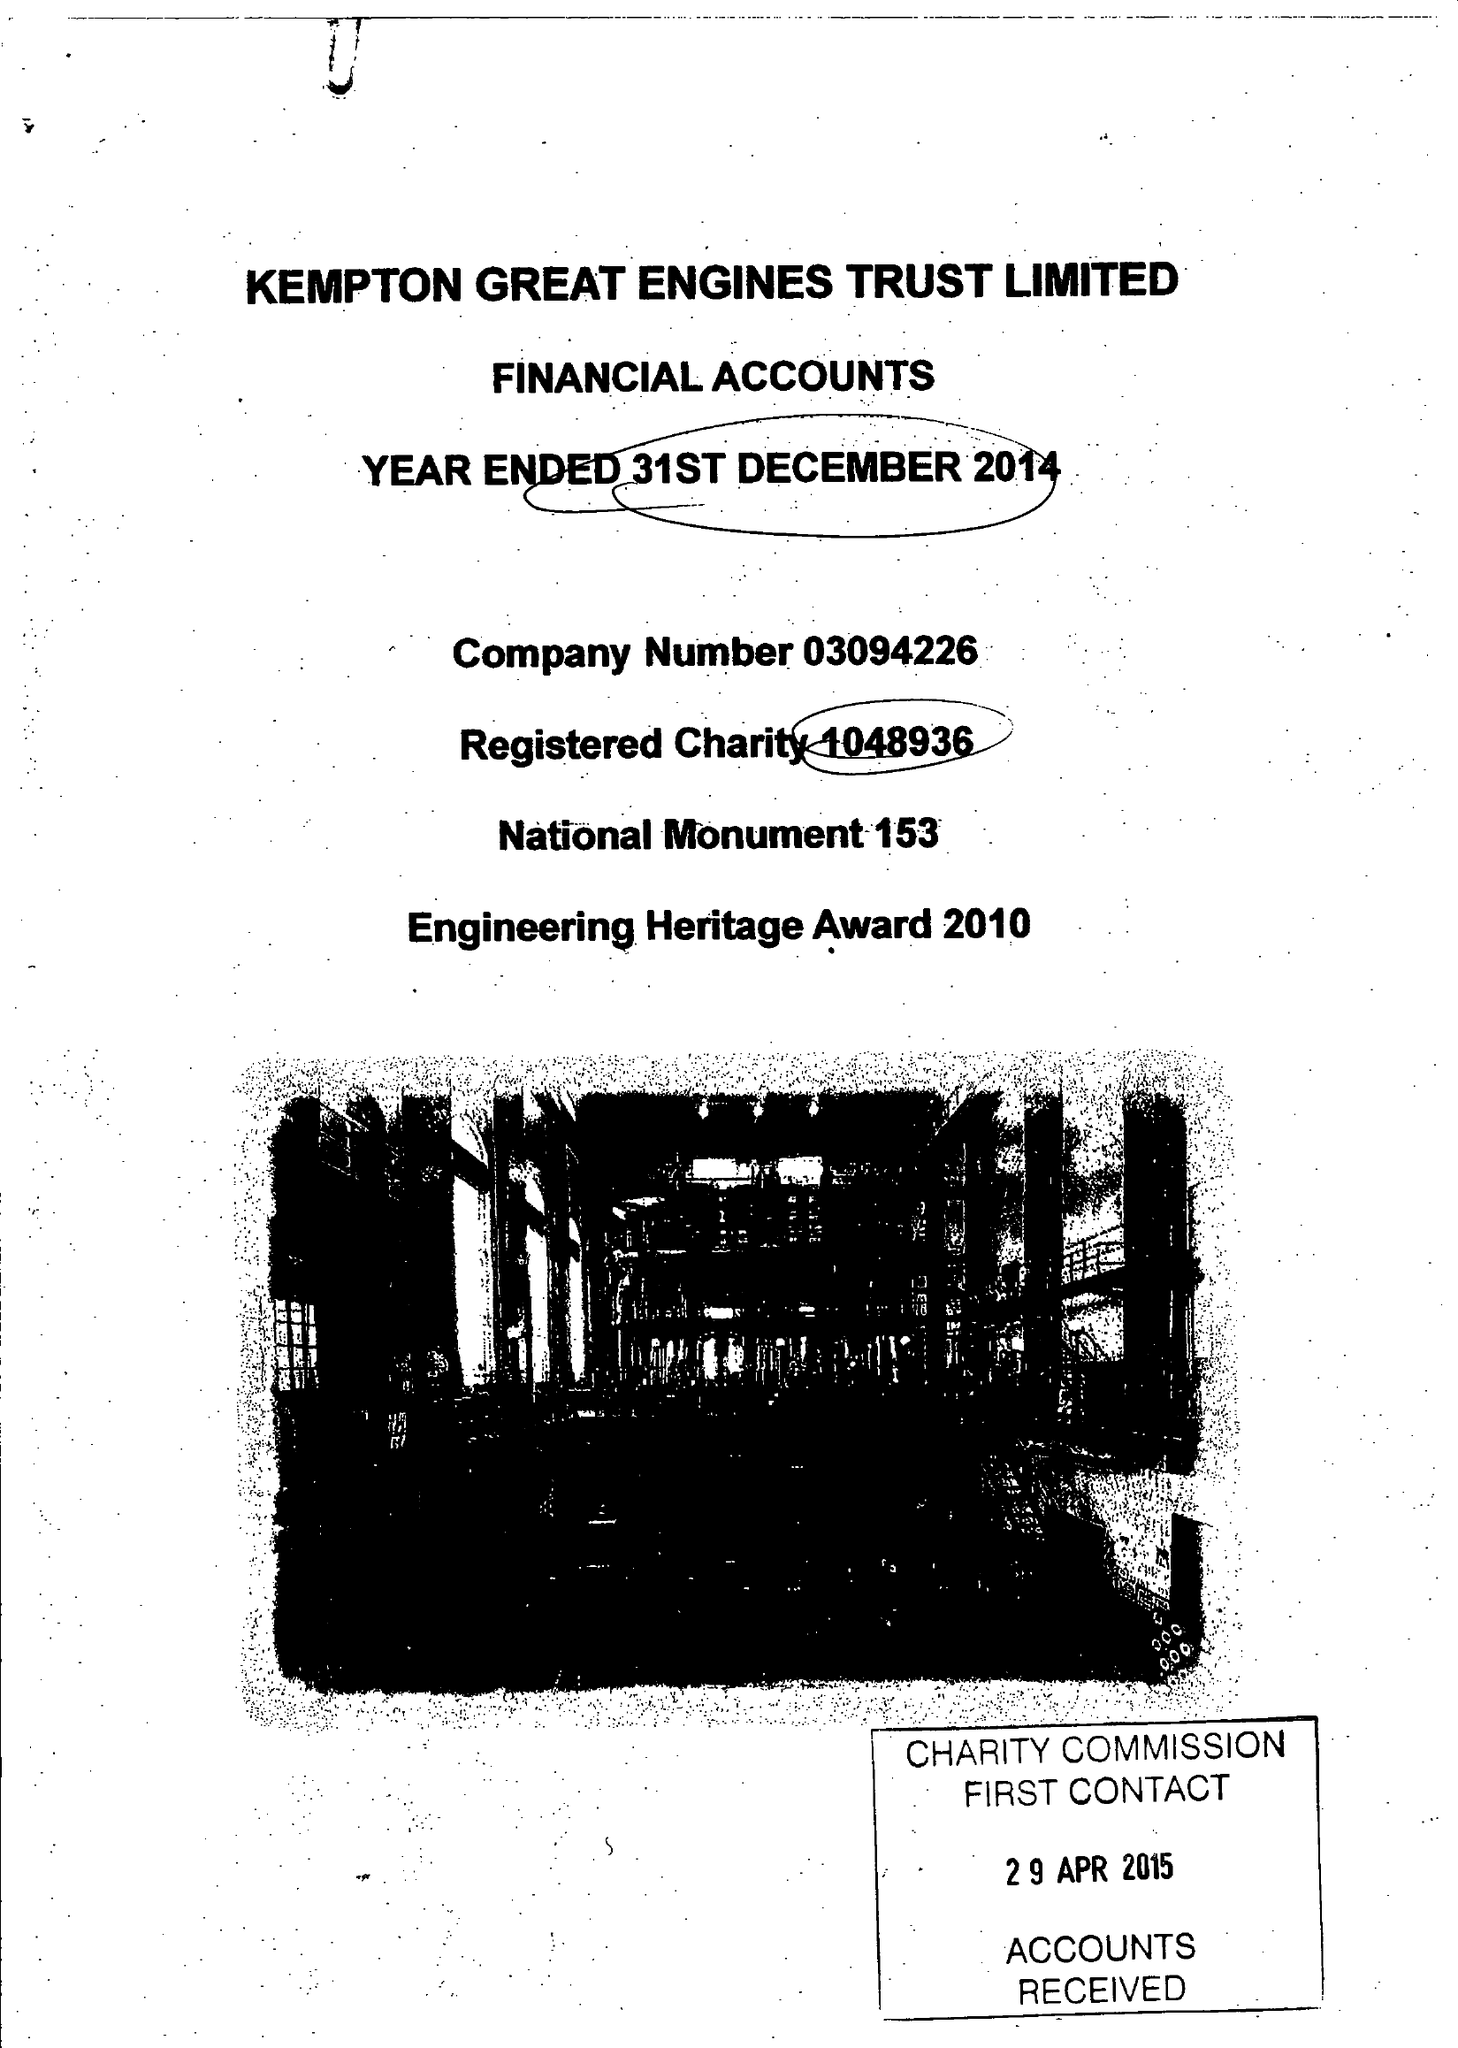What is the value for the charity_number?
Answer the question using a single word or phrase. 1048936 